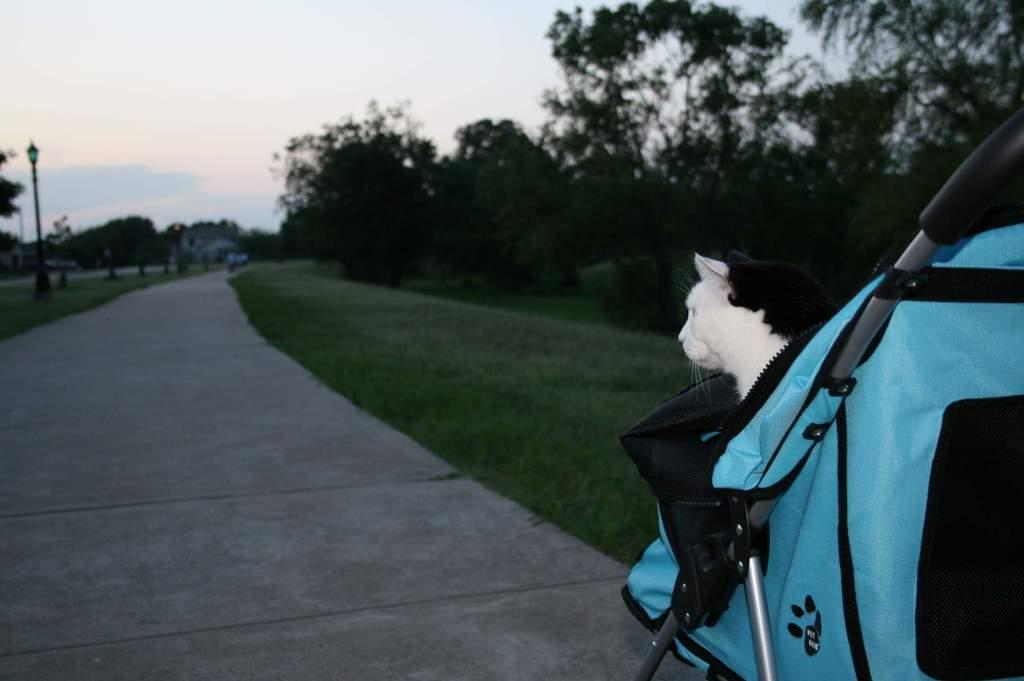Could you give a brief overview of what you see in this image? At the bottom of the picture, we see the road. Beside that, we see grass. On the right side, we see a blue color baby trolley in which we can see a white cat. On the left side, we see lights poles and trees. There are trees in the background. At the top, we see the sky. 